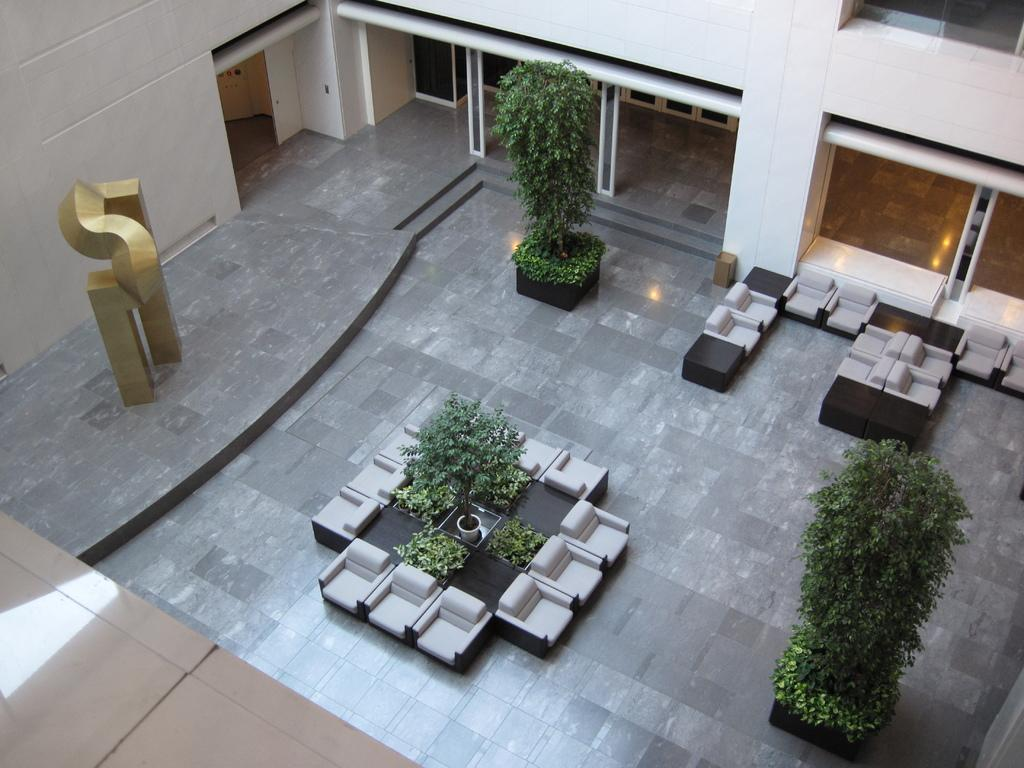What type of flooring is visible in the image? There is a tile floor in the image. What type of furniture can be seen in the image? There are chairs in the image. What type of container is present in the image? There is a bin in the image. What type of living organisms are in the image? There are plants in the image. What type of structure surrounds the area in the image? There are walls in the image. What type of objects are present in the image? There are objects in the image. What is the price of the wool in the image? There is no wool present in the image, so it is not possible to determine its price. 